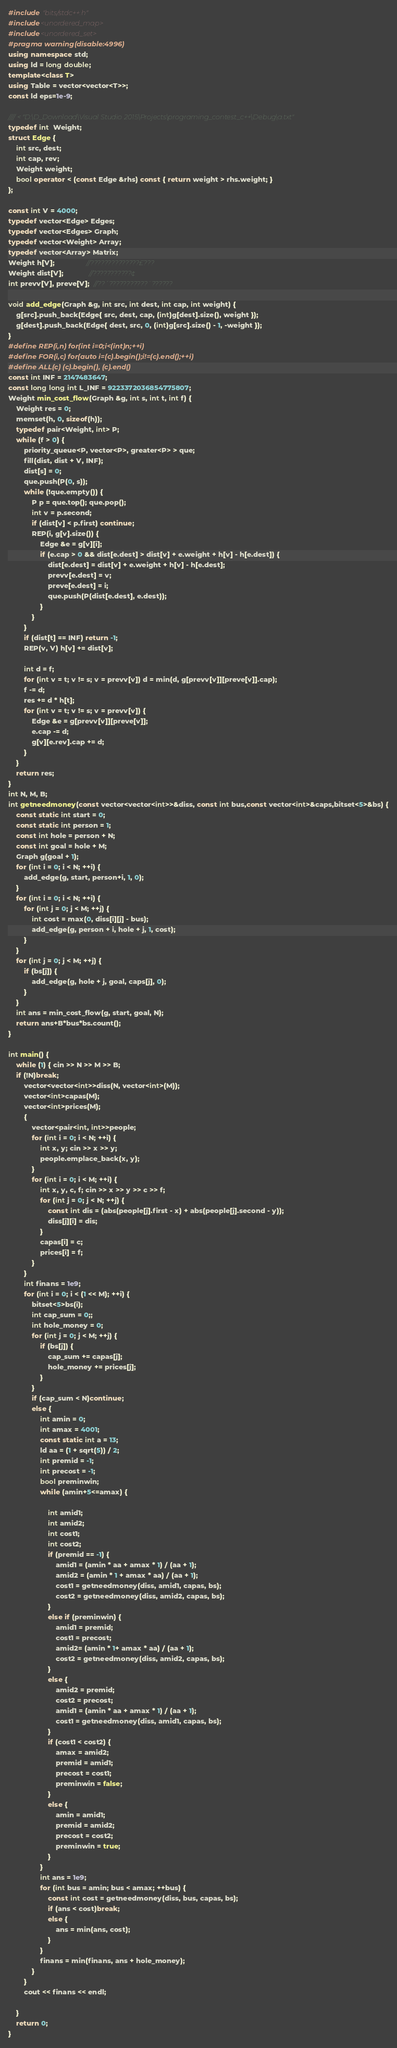Convert code to text. <code><loc_0><loc_0><loc_500><loc_500><_C++_>#include "bits/stdc++.h"
#include<unordered_map>
#include<unordered_set>
#pragma warning(disable:4996)
using namespace std;
using ld = long double;
template<class T>
using Table = vector<vector<T>>;
const ld eps=1e-9;

//// < "D:\D_Download\Visual Studio 2015\Projects\programing_contest_c++\Debug\a.txt"
typedef int  Weight;
struct Edge {
	int src, dest;
	int cap, rev;
	Weight weight;
	bool operator < (const Edge &rhs) const { return weight > rhs.weight; }
};

const int V = 4000;
typedef vector<Edge> Edges;
typedef vector<Edges> Graph;
typedef vector<Weight> Array;
typedef vector<Array> Matrix;
Weight h[V];                //??????????????£???
Weight dist[V];             //???????????¢
int prevv[V], preve[V];  //??´???????????¨??????

void add_edge(Graph &g, int src, int dest, int cap, int weight) {
	g[src].push_back(Edge{ src, dest, cap, (int)g[dest].size(), weight });
	g[dest].push_back(Edge{ dest, src, 0, (int)g[src].size() - 1, -weight });
}
#define REP(i,n) for(int i=0;i<(int)n;++i)
#define FOR(i,c) for(auto i=(c).begin();i!=(c).end();++i)
#define ALL(c) (c).begin(), (c).end()
const int INF = 2147483647;
const long long int L_INF = 9223372036854775807;
Weight min_cost_flow(Graph &g, int s, int t, int f) {
	Weight res = 0;
	memset(h, 0, sizeof(h));
	typedef pair<Weight, int> P;
	while (f > 0) {
		priority_queue<P, vector<P>, greater<P> > que;
		fill(dist, dist + V, INF);
		dist[s] = 0;
		que.push(P(0, s));
		while (!que.empty()) {
			P p = que.top(); que.pop();
			int v = p.second;
			if (dist[v] < p.first) continue;
			REP(i, g[v].size()) {
				Edge &e = g[v][i];
				if (e.cap > 0 && dist[e.dest] > dist[v] + e.weight + h[v] - h[e.dest]) {
					dist[e.dest] = dist[v] + e.weight + h[v] - h[e.dest];
					prevv[e.dest] = v;
					preve[e.dest] = i;
					que.push(P(dist[e.dest], e.dest));
				}
			}
		}
		if (dist[t] == INF) return -1;
		REP(v, V) h[v] += dist[v];

		int d = f;
		for (int v = t; v != s; v = prevv[v]) d = min(d, g[prevv[v]][preve[v]].cap);
		f -= d;
		res += d * h[t];
		for (int v = t; v != s; v = prevv[v]) {
			Edge &e = g[prevv[v]][preve[v]];
			e.cap -= d;
			g[v][e.rev].cap += d;
		}
	}
	return res;
}
int N, M, B;
int getneedmoney(const vector<vector<int>>&diss, const int bus,const vector<int>&caps,bitset<5>&bs) {
	const static int start = 0;
	const static int person = 1;
	const int hole = person + N;
	const int goal = hole + M;
	Graph g(goal + 1);
	for (int i = 0; i < N; ++i) {
		add_edge(g, start, person+i, 1, 0);
	}
	for (int i = 0; i < N; ++i) {
		for (int j = 0; j < M; ++j) {
			int cost = max(0, diss[i][j] - bus);
			add_edge(g, person + i, hole + j, 1, cost);
		}
	}
	for (int j = 0; j < M; ++j) {
		if (bs[j]) {
			add_edge(g, hole + j, goal, caps[j], 0);
		}
	}
	int ans = min_cost_flow(g, start, goal, N);
	return ans+B*bus*bs.count();
}

int main() {
	while (1) { cin >> N >> M >> B;
	if (!N)break;
		vector<vector<int>>diss(N, vector<int>(M));
		vector<int>capas(M);
		vector<int>prices(M);
		{
			vector<pair<int, int>>people;
			for (int i = 0; i < N; ++i) {
				int x, y; cin >> x >> y;
				people.emplace_back(x, y);
			}
			for (int i = 0; i < M; ++i) {
				int x, y, c, f; cin >> x >> y >> c >> f;
				for (int j = 0; j < N; ++j) {
					const int dis = (abs(people[j].first - x) + abs(people[j].second - y));
					diss[j][i] = dis;
				}
				capas[i] = c;
				prices[i] = f;
			}
		}
		int finans = 1e9;
		for (int i = 0; i < (1 << M); ++i) {
			bitset<5>bs(i);
			int cap_sum = 0;;
			int hole_money = 0;
			for (int j = 0; j < M; ++j) {
				if (bs[j]) {
					cap_sum += capas[j];
					hole_money += prices[j];
				}
			}
			if (cap_sum < N)continue;
			else {
				int amin = 0;
				int amax = 4001;
				const static int a = 13;
				ld aa = (1 + sqrt(5)) / 2;
				int premid = -1;
				int precost = -1;
				bool preminwin;
				while (amin+5<=amax) {
					
					int amid1;
					int amid2;
					int cost1;
					int cost2;
					if (premid == -1) {
						amid1 = (amin * aa + amax * 1) / (aa + 1);
						amid2 = (amin * 1 + amax * aa) / (aa + 1);
						cost1 = getneedmoney(diss, amid1, capas, bs);
						cost2 = getneedmoney(diss, amid2, capas, bs);
					}
					else if (preminwin) {
						amid1 = premid;
						cost1 = precost;
						amid2= (amin * 1+ amax * aa) / (aa + 1);
						cost2 = getneedmoney(diss, amid2, capas, bs);
					}
					else {
						amid2 = premid;
						cost2 = precost;
						amid1 = (amin * aa + amax * 1) / (aa + 1);
						cost1 = getneedmoney(diss, amid1, capas, bs);
					}
					if (cost1 < cost2) {
						amax = amid2;
						premid = amid1;
						precost = cost1;
						preminwin = false;
					}
					else {
						amin = amid1;
						premid = amid2;
						precost = cost2;
						preminwin = true;
					}
				}
				int ans = 1e9;
				for (int bus = amin; bus < amax; ++bus) {
					const int cost = getneedmoney(diss, bus, capas, bs);
					if (ans < cost)break;
					else {
						ans = min(ans, cost);
					}
				}
				finans = min(finans, ans + hole_money);
			}
		}
		cout << finans << endl;
		
	}
	return 0;
}</code> 